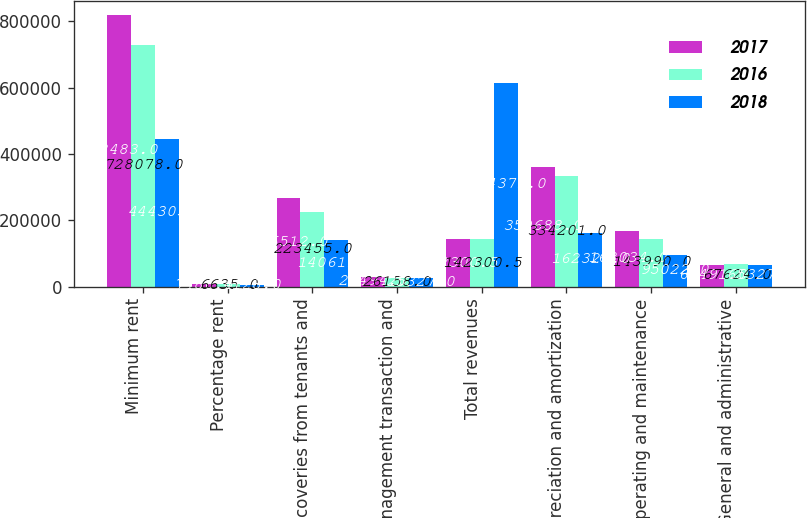<chart> <loc_0><loc_0><loc_500><loc_500><stacked_bar_chart><ecel><fcel>Minimum rent<fcel>Percentage rent<fcel>Recoveries from tenants and<fcel>Management transaction and<fcel>Total revenues<fcel>Depreciation and amortization<fcel>Operating and maintenance<fcel>General and administrative<nl><fcel>2017<fcel>818483<fcel>7486<fcel>266512<fcel>28494<fcel>142300<fcel>359688<fcel>168034<fcel>65491<nl><fcel>2016<fcel>728078<fcel>6635<fcel>223455<fcel>26158<fcel>142300<fcel>334201<fcel>143990<fcel>67624<nl><fcel>2018<fcel>444305<fcel>4128<fcel>140611<fcel>25327<fcel>614371<fcel>162327<fcel>95022<fcel>65327<nl></chart> 